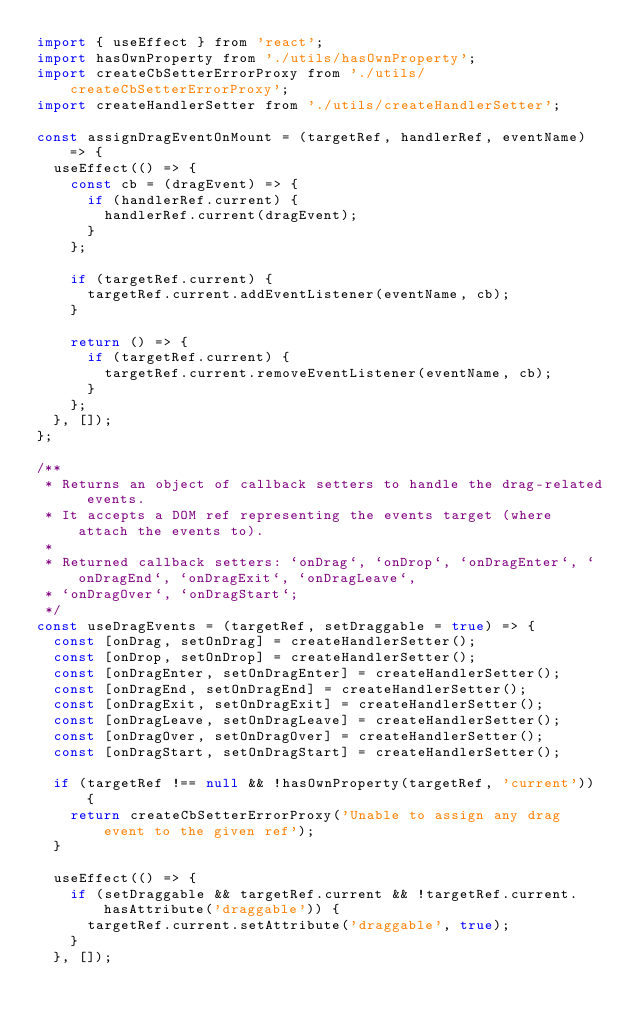Convert code to text. <code><loc_0><loc_0><loc_500><loc_500><_JavaScript_>import { useEffect } from 'react';
import hasOwnProperty from './utils/hasOwnProperty';
import createCbSetterErrorProxy from './utils/createCbSetterErrorProxy';
import createHandlerSetter from './utils/createHandlerSetter';

const assignDragEventOnMount = (targetRef, handlerRef, eventName) => {
  useEffect(() => {
    const cb = (dragEvent) => {
      if (handlerRef.current) {
        handlerRef.current(dragEvent);
      }
    };

    if (targetRef.current) {
      targetRef.current.addEventListener(eventName, cb);
    }

    return () => {
      if (targetRef.current) {
        targetRef.current.removeEventListener(eventName, cb);
      }
    };
  }, []);
};

/**
 * Returns an object of callback setters to handle the drag-related events.
 * It accepts a DOM ref representing the events target (where attach the events to).
 *
 * Returned callback setters: `onDrag`, `onDrop`, `onDragEnter`, `onDragEnd`, `onDragExit`, `onDragLeave`,
 * `onDragOver`, `onDragStart`;
 */
const useDragEvents = (targetRef, setDraggable = true) => {
  const [onDrag, setOnDrag] = createHandlerSetter();
  const [onDrop, setOnDrop] = createHandlerSetter();
  const [onDragEnter, setOnDragEnter] = createHandlerSetter();
  const [onDragEnd, setOnDragEnd] = createHandlerSetter();
  const [onDragExit, setOnDragExit] = createHandlerSetter();
  const [onDragLeave, setOnDragLeave] = createHandlerSetter();
  const [onDragOver, setOnDragOver] = createHandlerSetter();
  const [onDragStart, setOnDragStart] = createHandlerSetter();

  if (targetRef !== null && !hasOwnProperty(targetRef, 'current')) {
    return createCbSetterErrorProxy('Unable to assign any drag event to the given ref');
  }

  useEffect(() => {
    if (setDraggable && targetRef.current && !targetRef.current.hasAttribute('draggable')) {
      targetRef.current.setAttribute('draggable', true);
    }
  }, []);
</code> 